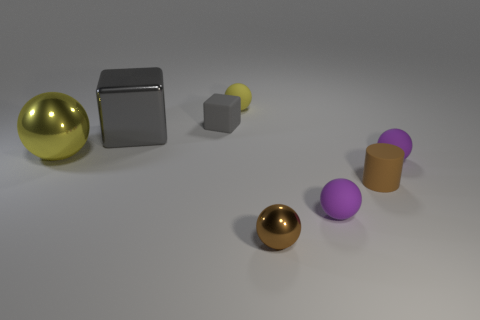Subtract 2 spheres. How many spheres are left? 3 Subtract all yellow shiny spheres. How many spheres are left? 4 Subtract all brown balls. How many balls are left? 4 Subtract all blue blocks. Subtract all brown cylinders. How many blocks are left? 2 Add 2 tiny blue objects. How many objects exist? 10 Subtract all balls. How many objects are left? 3 Add 3 big gray shiny things. How many big gray shiny things exist? 4 Subtract 0 cyan blocks. How many objects are left? 8 Subtract all small purple balls. Subtract all small metallic spheres. How many objects are left? 5 Add 1 brown objects. How many brown objects are left? 3 